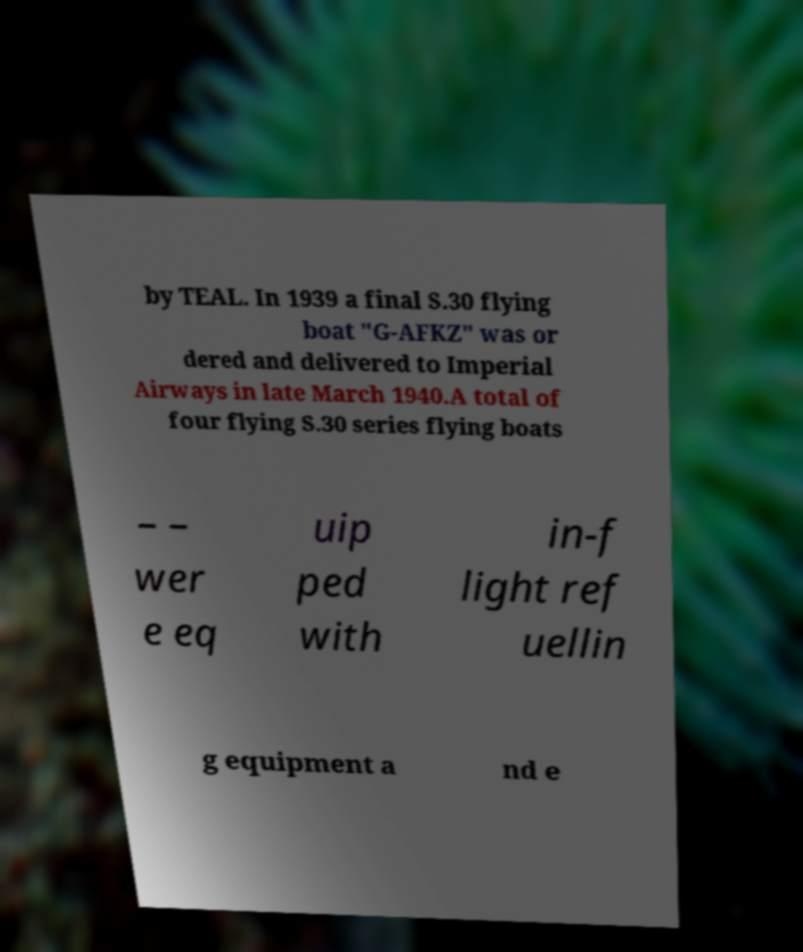What messages or text are displayed in this image? I need them in a readable, typed format. by TEAL. In 1939 a final S.30 flying boat "G-AFKZ" was or dered and delivered to Imperial Airways in late March 1940.A total of four flying S.30 series flying boats – – wer e eq uip ped with in-f light ref uellin g equipment a nd e 